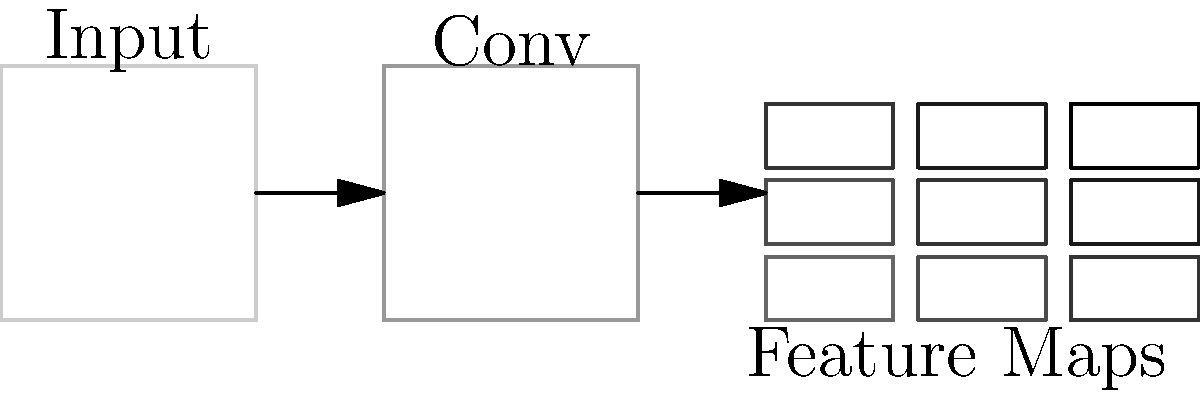In the context of convolutional neural networks (CNNs), what is the primary purpose of the feature maps shown in the diagram, and how do they relate to image classification tasks? To understand the role of feature maps in CNNs and their relation to image classification, let's break it down step-by-step:

1. Input Image: The process starts with an input image, represented by the leftmost box in the diagram.

2. Convolutional Layer: The input image passes through a convolutional layer (labeled "Conv" in the diagram). This layer applies multiple filters to the input image.

3. Feature Maps: The output of the convolutional layer is a set of feature maps, shown as the 3x3 grid on the right side of the diagram.

4. Purpose of Feature Maps:
   a) Feature Detection: Each feature map represents the activation of a specific filter across the image. Different filters detect different features (e.g., edges, textures, shapes).
   b) Spatial Information: Feature maps preserve the spatial relationships between features in the original image.
   c) Hierarchical Representation: In deeper layers of the network, feature maps represent increasingly complex and abstract features.

5. Relation to Image Classification:
   a) Feature Extraction: The feature maps collectively capture essential characteristics of the input image.
   b) Dimensionality Reduction: They compress the input information into a more manageable form.
   c) Learnable Representations: The network learns which features are most relevant for classification during training.
   d) Input to Fully Connected Layers: These feature maps are typically flattened and fed into fully connected layers for final classification.

6. Importance in Classification:
   The rich, hierarchical representation provided by feature maps allows the network to distinguish between different classes of images effectively. The more discriminative the features captured in these maps, the better the network's classification performance.
Answer: Feature maps capture and represent hierarchical image features, enabling effective image classification by providing learnable, spatially-aware representations of input data. 